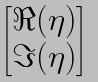<formula> <loc_0><loc_0><loc_500><loc_500>\begin{bmatrix} \Re ( \eta ) \\ \Im ( \eta ) \end{bmatrix}</formula> 